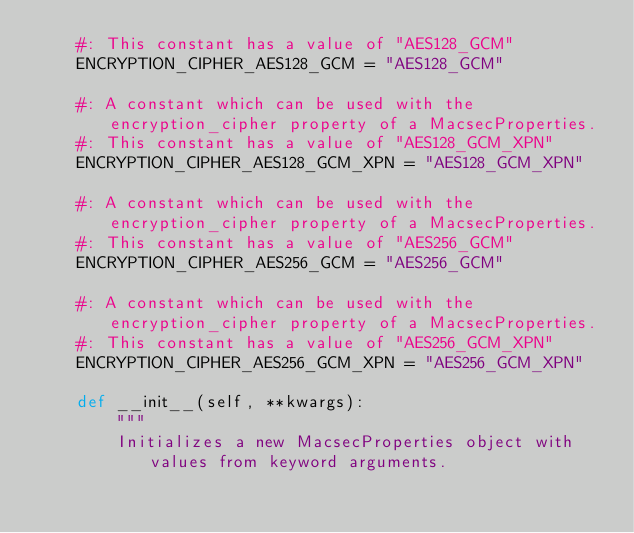<code> <loc_0><loc_0><loc_500><loc_500><_Python_>    #: This constant has a value of "AES128_GCM"
    ENCRYPTION_CIPHER_AES128_GCM = "AES128_GCM"

    #: A constant which can be used with the encryption_cipher property of a MacsecProperties.
    #: This constant has a value of "AES128_GCM_XPN"
    ENCRYPTION_CIPHER_AES128_GCM_XPN = "AES128_GCM_XPN"

    #: A constant which can be used with the encryption_cipher property of a MacsecProperties.
    #: This constant has a value of "AES256_GCM"
    ENCRYPTION_CIPHER_AES256_GCM = "AES256_GCM"

    #: A constant which can be used with the encryption_cipher property of a MacsecProperties.
    #: This constant has a value of "AES256_GCM_XPN"
    ENCRYPTION_CIPHER_AES256_GCM_XPN = "AES256_GCM_XPN"

    def __init__(self, **kwargs):
        """
        Initializes a new MacsecProperties object with values from keyword arguments.</code> 